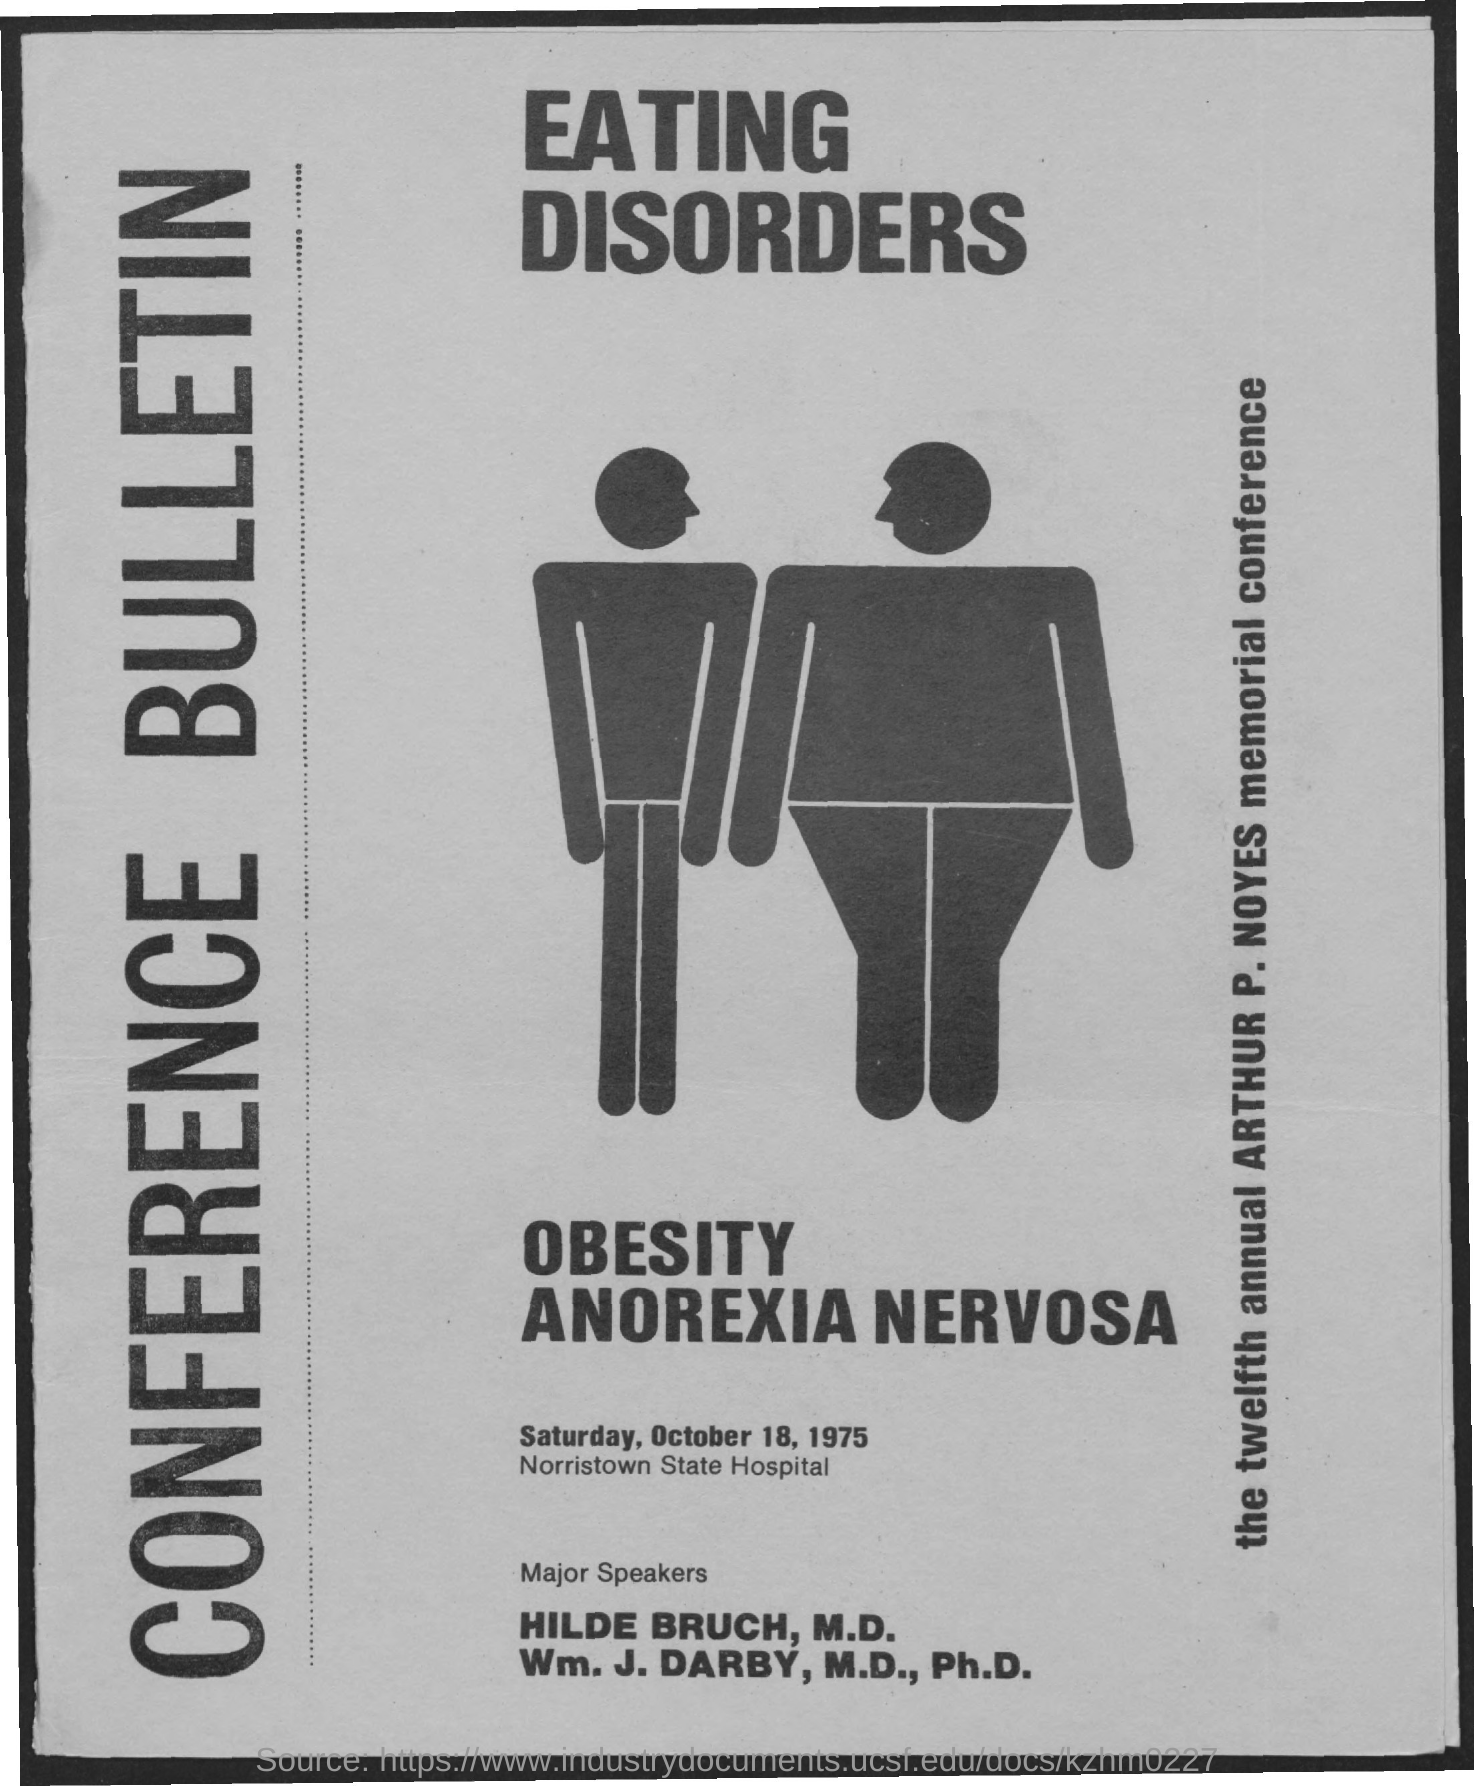When is the conference?
Provide a short and direct response. SATURDAY, OCTOBER 18, 1975. Where is the Conference?
Ensure brevity in your answer.  NORRISTOWN STATE HOSPITAL. 